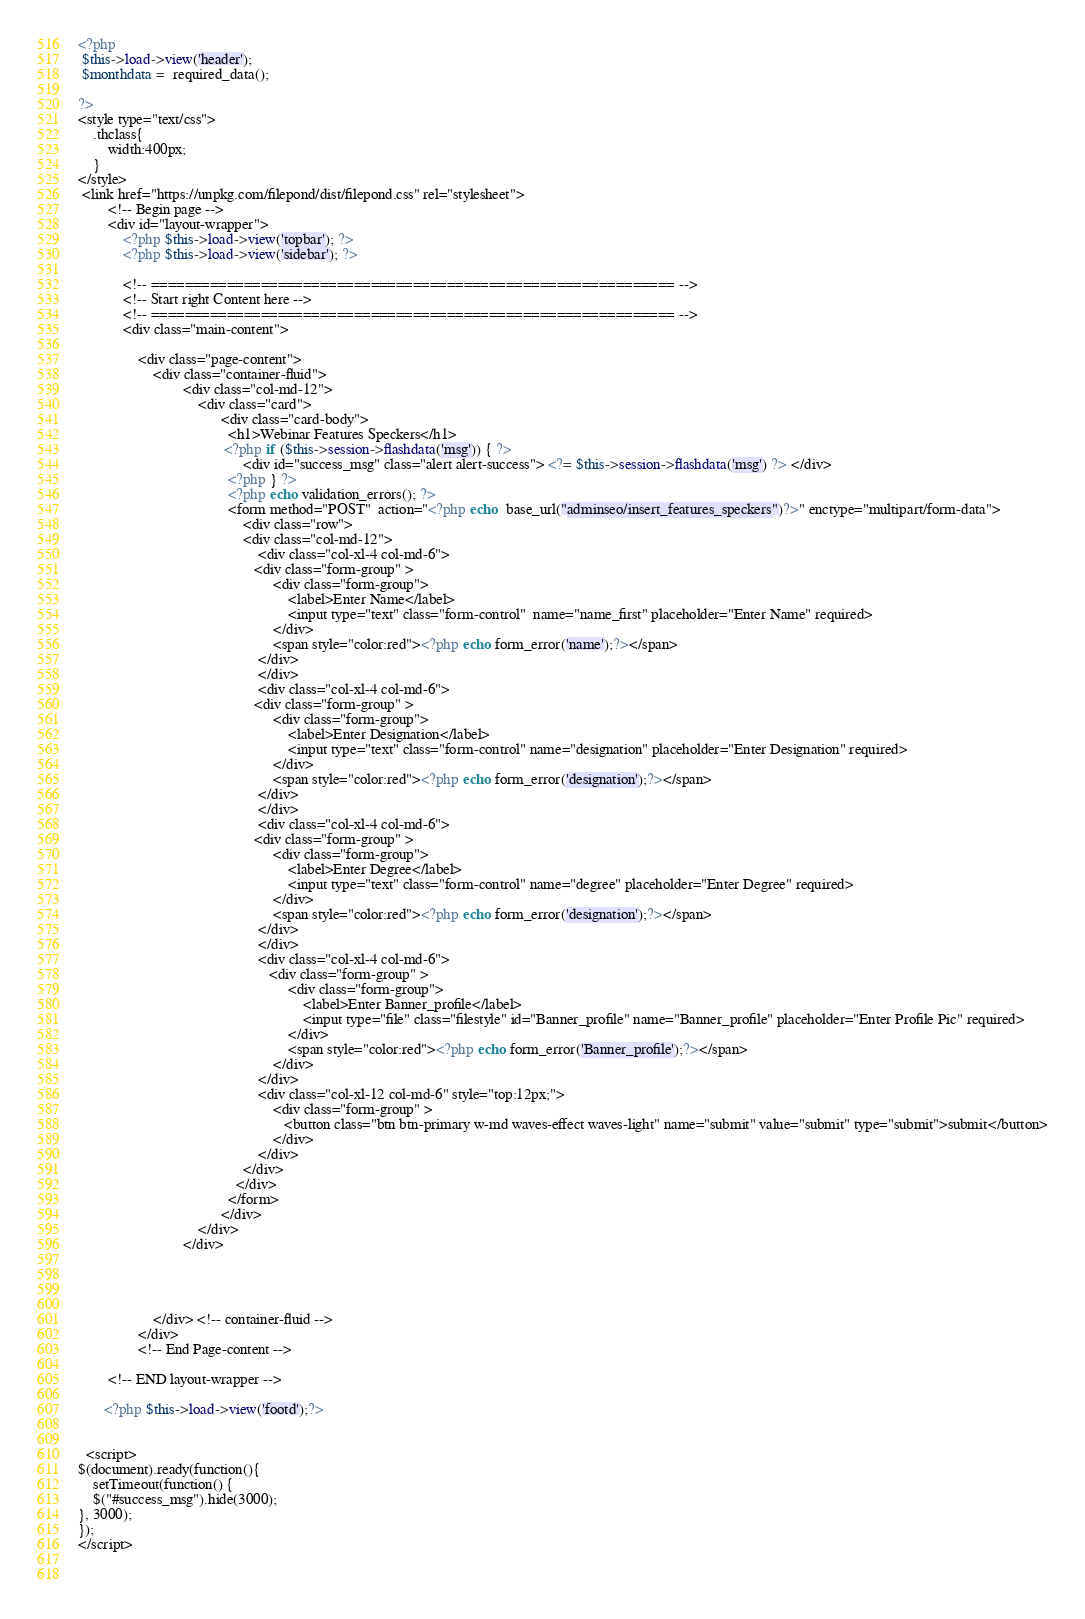Convert code to text. <code><loc_0><loc_0><loc_500><loc_500><_PHP_><?php
 $this->load->view('header');
 $monthdata =  required_data();

?>
<style type="text/css">
    .thclass{
        width:400px;
    }
</style>
 <link href="https://unpkg.com/filepond/dist/filepond.css" rel="stylesheet">
        <!-- Begin page -->
        <div id="layout-wrapper">
            <?php $this->load->view('topbar'); ?>
            <?php $this->load->view('sidebar'); ?>

            <!-- ============================================================== -->
            <!-- Start right Content here -->
            <!-- ============================================================== -->
            <div class="main-content">

                <div class="page-content">
                    <div class="container-fluid">
                            <div class="col-md-12">
                                <div class="card">
                                      <div class="card-body">
                                        <h1>Webinar Features Speckers</h1>
                                       <?php if ($this->session->flashdata('msg')) { ?>
                                            <div id="success_msg" class="alert alert-success"> <?= $this->session->flashdata('msg') ?> </div>
                                        <?php } ?>
                                        <?php echo validation_errors(); ?>
                                        <form method="POST"  action="<?php echo  base_url("adminseo/insert_features_speckers")?>" enctype="multipart/form-data">
                                            <div class="row">
                                            <div class="col-md-12">
                                                <div class="col-xl-4 col-md-6">
                                               <div class="form-group" >
                                                    <div class="form-group">
                                                        <label>Enter Name</label>
                                                        <input type="text" class="form-control"  name="name_first" placeholder="Enter Name" required>
                                                    </div>
                                                    <span style="color:red"><?php echo form_error('name');?></span>
                                                </div>
                                                </div>
                                                <div class="col-xl-4 col-md-6">
                                               <div class="form-group" >
                                                    <div class="form-group">
                                                        <label>Enter Designation</label>
                                                        <input type="text" class="form-control" name="designation" placeholder="Enter Designation" required>
                                                    </div>
                                                    <span style="color:red"><?php echo form_error('designation');?></span>
                                                </div>
                                                </div>
                                                <div class="col-xl-4 col-md-6">
                                               <div class="form-group" >
                                                    <div class="form-group">
                                                        <label>Enter Degree</label>
                                                        <input type="text" class="form-control" name="degree" placeholder="Enter Degree" required>
                                                    </div>
                                                    <span style="color:red"><?php echo form_error('designation');?></span>
                                                </div>
                                                </div>
                                                <div class="col-xl-4 col-md-6">
                                                   <div class="form-group" >
                                                        <div class="form-group">
                                                            <label>Enter Banner_profile</label>
                                                            <input type="file" class="filestyle" id="Banner_profile" name="Banner_profile" placeholder="Enter Profile Pic" required>
                                                        </div>
                                                        <span style="color:red"><?php echo form_error('Banner_profile');?></span>
                                                    </div>
                                                </div>
                                                <div class="col-xl-12 col-md-6" style="top:12px;">
                                                    <div class="form-group" >
                                                       <button class="btn btn-primary w-md waves-effect waves-light" name="submit" value="submit" type="submit">submit</button>
                                                    </div>
                                                </div>
                                            </div>
                                          </div>
                                        </form>
                                      </div>
                                </div>
                            </div>
                       

                        

                    </div> <!-- container-fluid -->
                </div>
                <!-- End Page-content -->

        <!-- END layout-wrapper -->

       <?php $this->load->view('footd');?>
  

  <script>
$(document).ready(function(){
    setTimeout(function() {
    $("#success_msg").hide(3000);
}, 3000); 
});
</script>

    </code> 